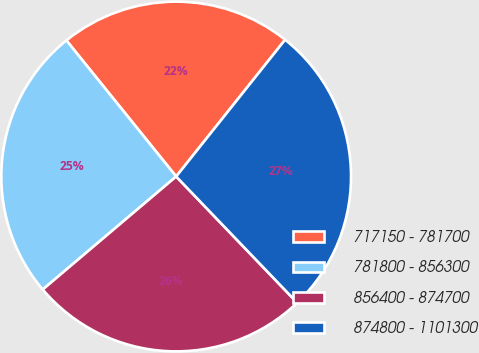Convert chart to OTSL. <chart><loc_0><loc_0><loc_500><loc_500><pie_chart><fcel>717150 - 781700<fcel>781800 - 856300<fcel>856400 - 874700<fcel>874800 - 1101300<nl><fcel>21.51%<fcel>25.38%<fcel>25.98%<fcel>27.13%<nl></chart> 